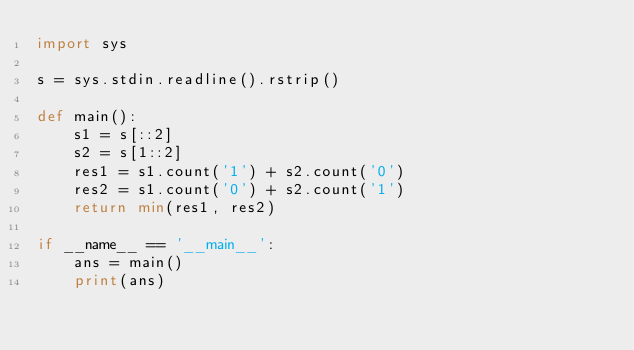<code> <loc_0><loc_0><loc_500><loc_500><_Python_>import sys

s = sys.stdin.readline().rstrip()

def main():
    s1 = s[::2]
    s2 = s[1::2]
    res1 = s1.count('1') + s2.count('0')
    res2 = s1.count('0') + s2.count('1')
    return min(res1, res2)

if __name__ == '__main__':
    ans = main()
    print(ans)</code> 